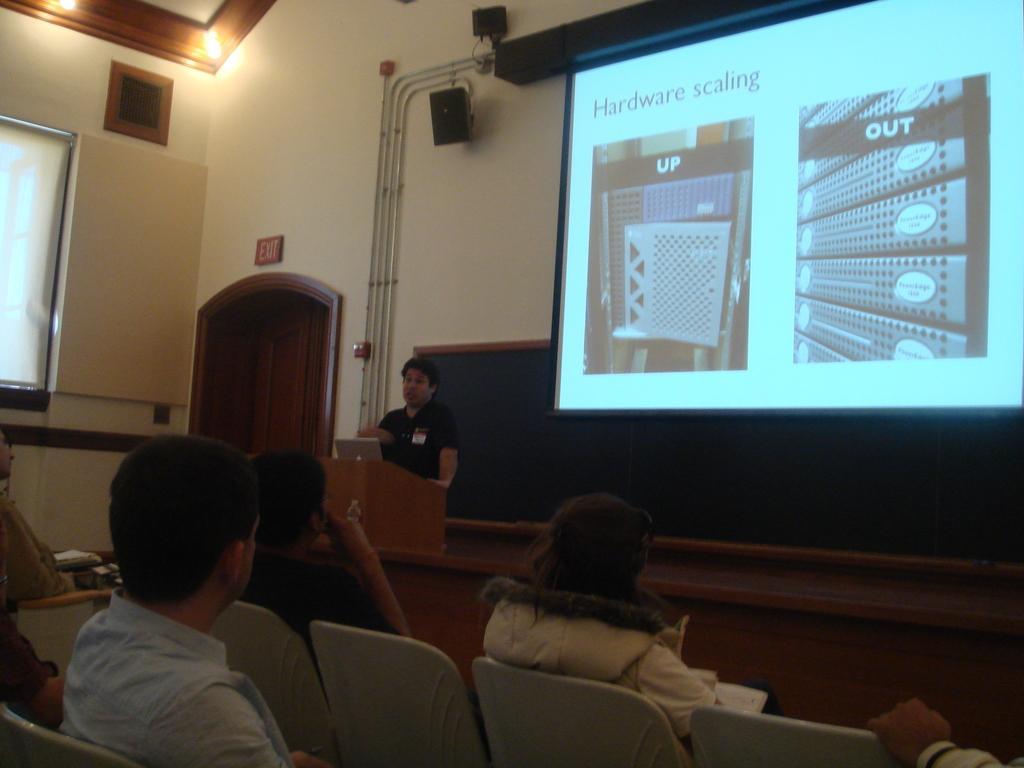In one or two sentences, can you explain what this image depicts? In the image I can see some people sitting in front of the projector screen and to the side there is a person who is standing in front of the desk on which there is a laptop and around there are some speakers, boards and some lights. 